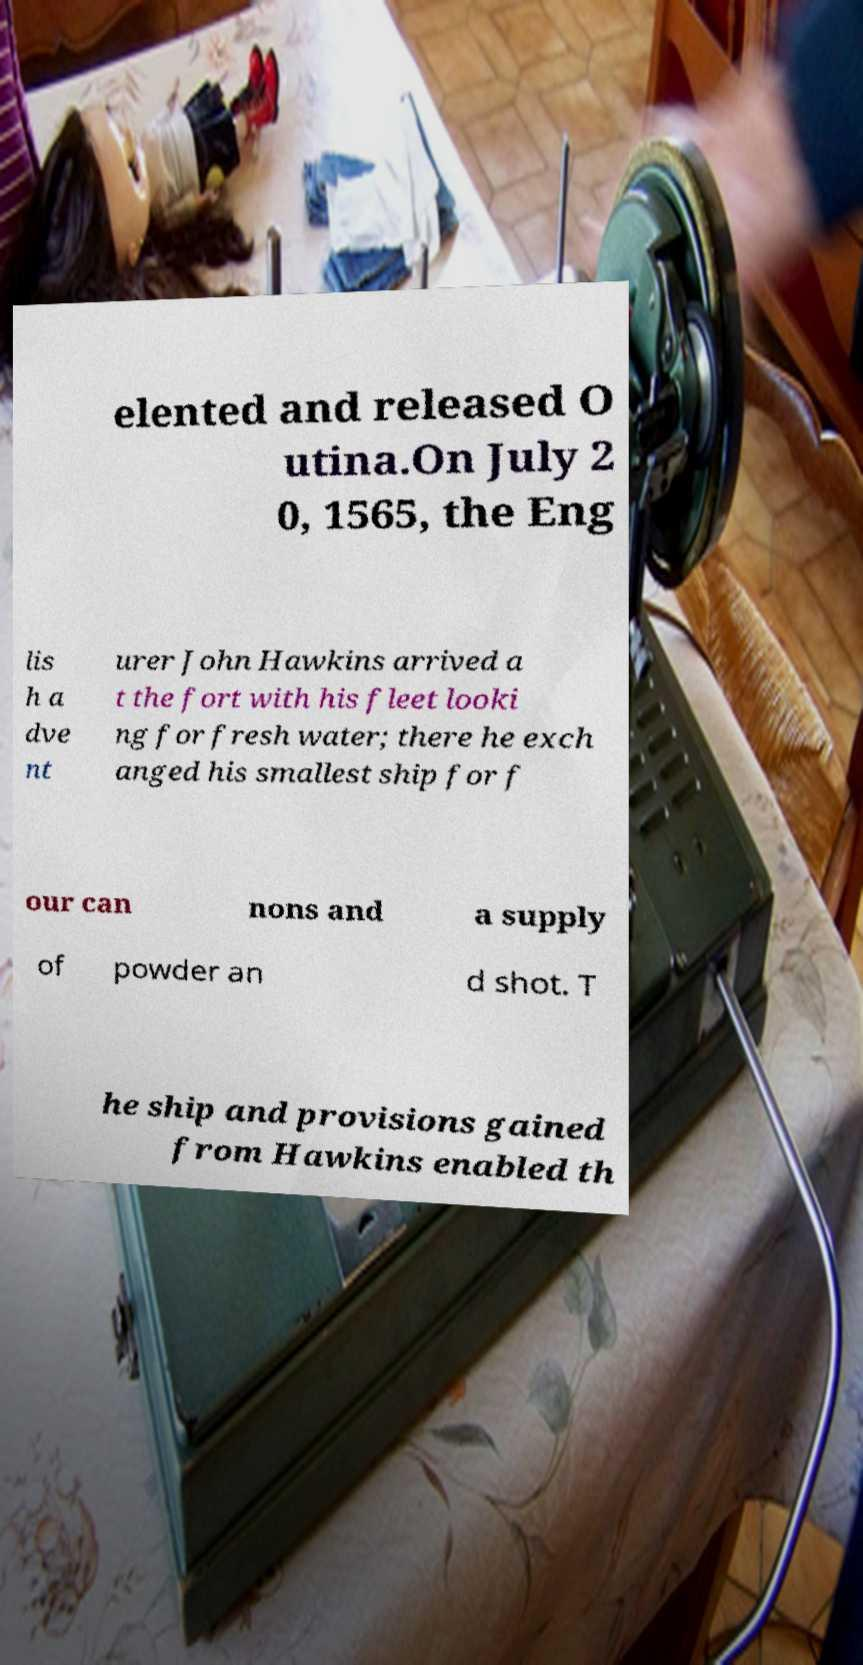Can you accurately transcribe the text from the provided image for me? elented and released O utina.On July 2 0, 1565, the Eng lis h a dve nt urer John Hawkins arrived a t the fort with his fleet looki ng for fresh water; there he exch anged his smallest ship for f our can nons and a supply of powder an d shot. T he ship and provisions gained from Hawkins enabled th 